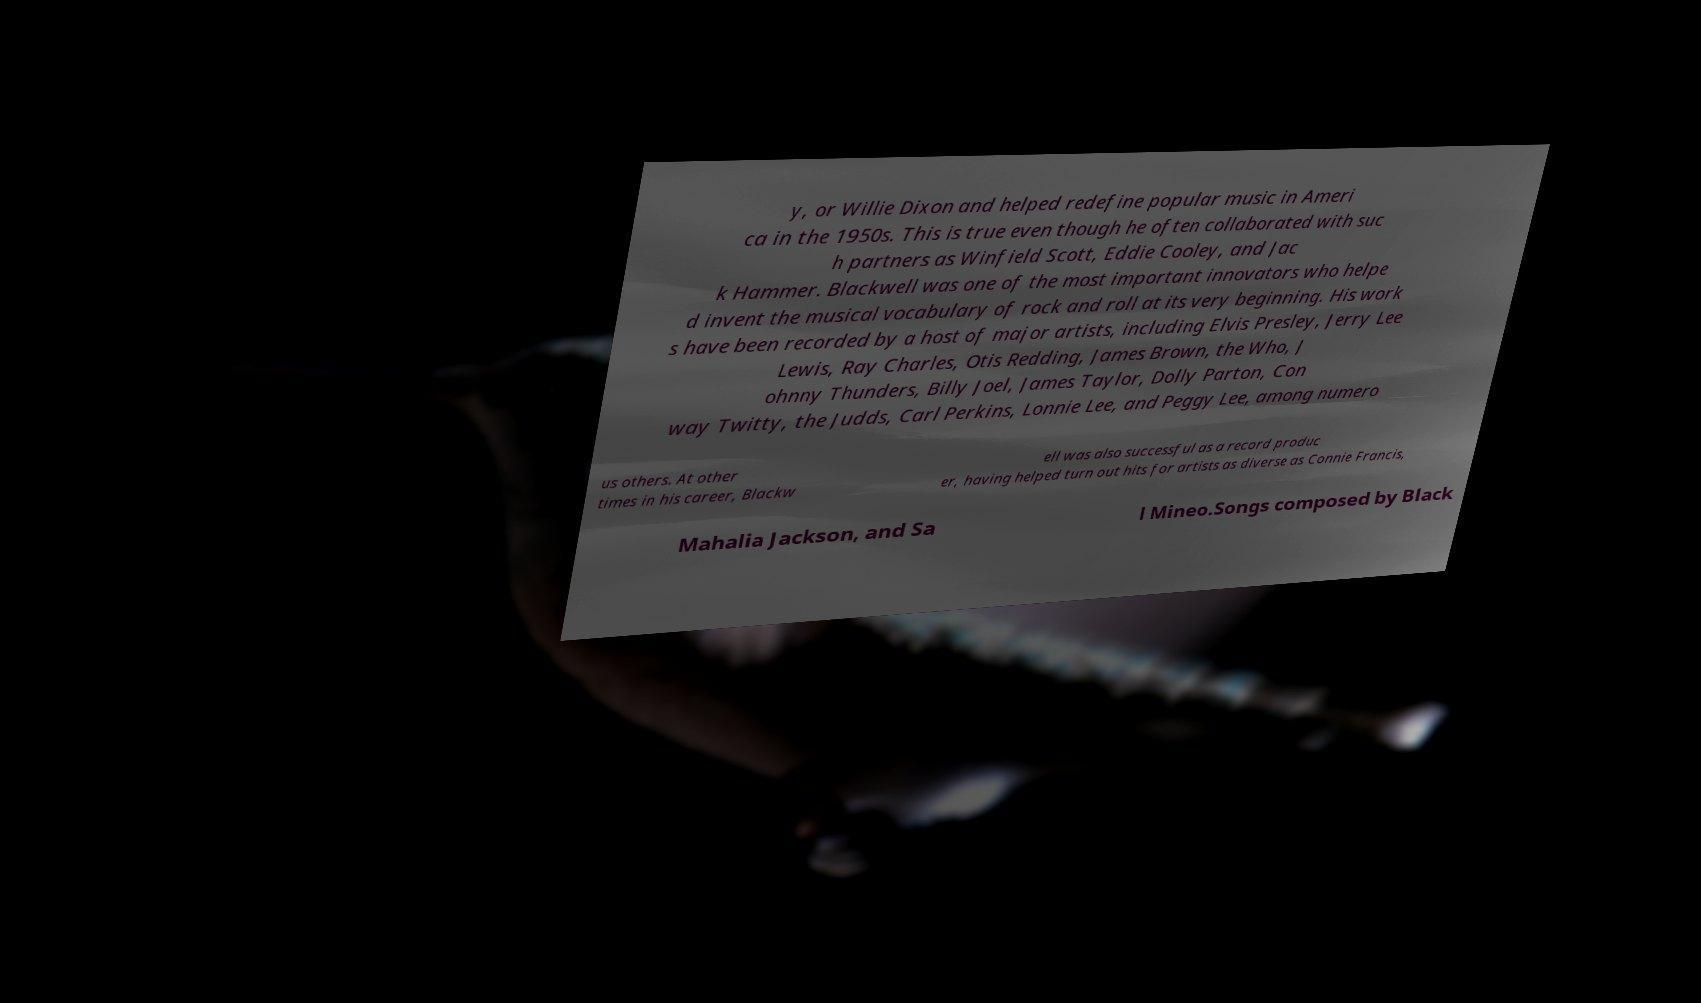Can you accurately transcribe the text from the provided image for me? y, or Willie Dixon and helped redefine popular music in Ameri ca in the 1950s. This is true even though he often collaborated with suc h partners as Winfield Scott, Eddie Cooley, and Jac k Hammer. Blackwell was one of the most important innovators who helpe d invent the musical vocabulary of rock and roll at its very beginning. His work s have been recorded by a host of major artists, including Elvis Presley, Jerry Lee Lewis, Ray Charles, Otis Redding, James Brown, the Who, J ohnny Thunders, Billy Joel, James Taylor, Dolly Parton, Con way Twitty, the Judds, Carl Perkins, Lonnie Lee, and Peggy Lee, among numero us others. At other times in his career, Blackw ell was also successful as a record produc er, having helped turn out hits for artists as diverse as Connie Francis, Mahalia Jackson, and Sa l Mineo.Songs composed by Black 